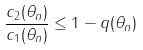<formula> <loc_0><loc_0><loc_500><loc_500>\frac { c _ { 2 } ( \theta _ { n } ) } { c _ { 1 } ( \theta _ { n } ) } \leq 1 - q ( \theta _ { n } )</formula> 